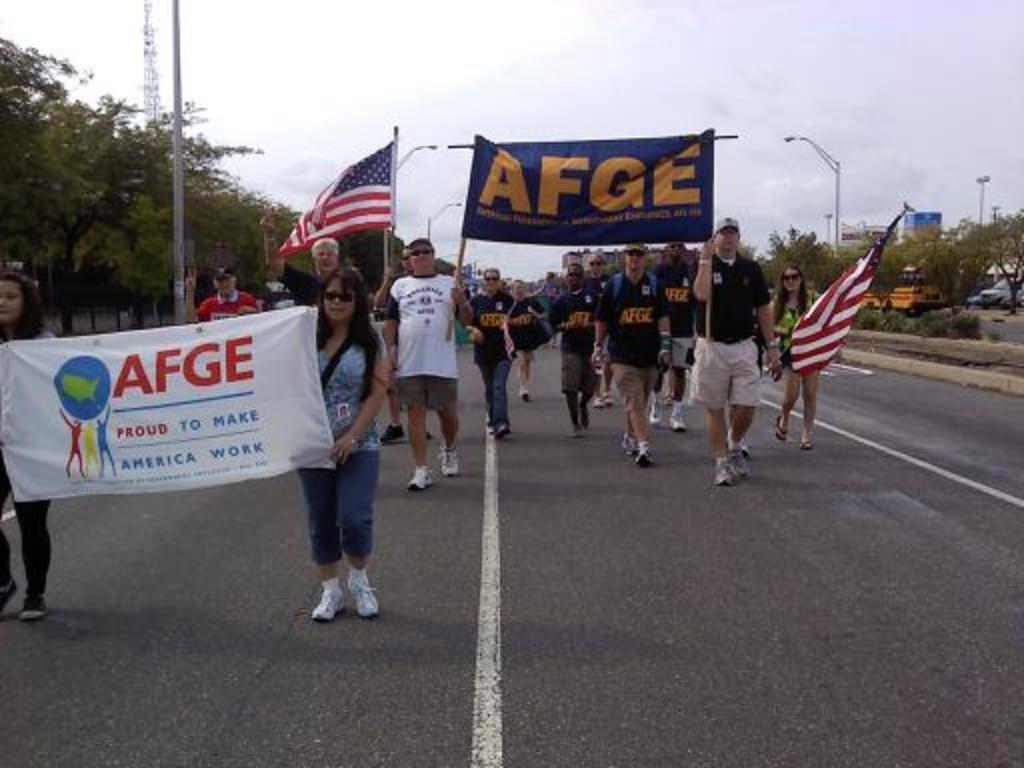Describe this image in one or two sentences. In this picture we can see some people are walking on the road and they are holding some banners and flags, beside the road some trees and buildings are placed. 